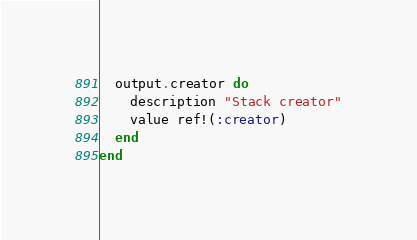<code> <loc_0><loc_0><loc_500><loc_500><_Ruby_>  output.creator do
    description "Stack creator"
    value ref!(:creator)
  end
end
</code> 